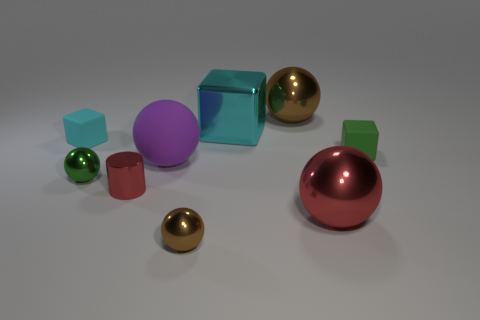Subtract 2 spheres. How many spheres are left? 3 Subtract all large purple balls. How many balls are left? 4 Subtract all green spheres. How many spheres are left? 4 Subtract all gray spheres. Subtract all blue cylinders. How many spheres are left? 5 Subtract all cylinders. How many objects are left? 8 Subtract 0 blue cylinders. How many objects are left? 9 Subtract all big gray rubber spheres. Subtract all tiny green blocks. How many objects are left? 8 Add 2 large cyan metallic things. How many large cyan metallic things are left? 3 Add 6 large brown spheres. How many large brown spheres exist? 7 